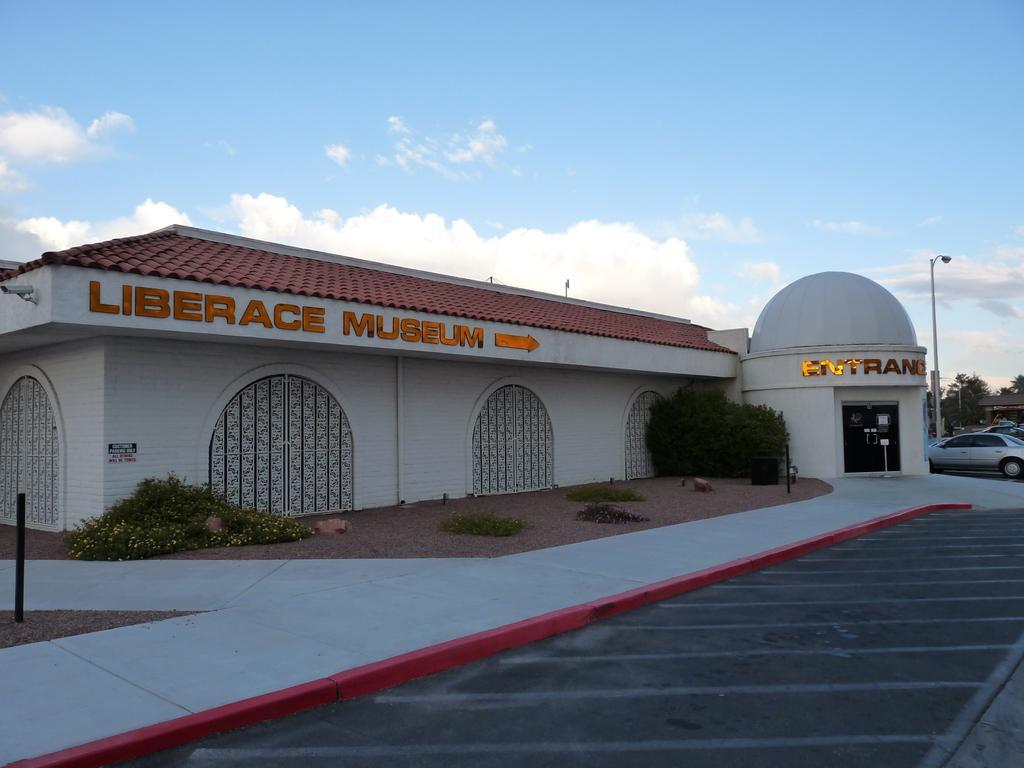Describe this image in one or two sentences. In the center of the image there is a building and we can see bushes. At the bottom there is a road and we can see cars. In the background there are poles, trees and sky. 